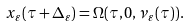<formula> <loc_0><loc_0><loc_500><loc_500>x _ { \varepsilon } ( \tau + \Delta _ { \varepsilon } ) = \Omega ( \tau , 0 , \nu _ { \varepsilon } ( \tau ) ) .</formula> 